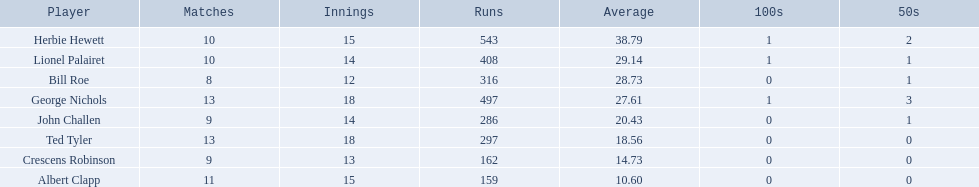Who are the team members in somerset county cricket club in 1890? Herbie Hewett, Lionel Palairet, Bill Roe, George Nichols, John Challen, Ted Tyler, Crescens Robinson, Albert Clapp. Who is the only individual to appear in under 13 innings? Bill Roe. 